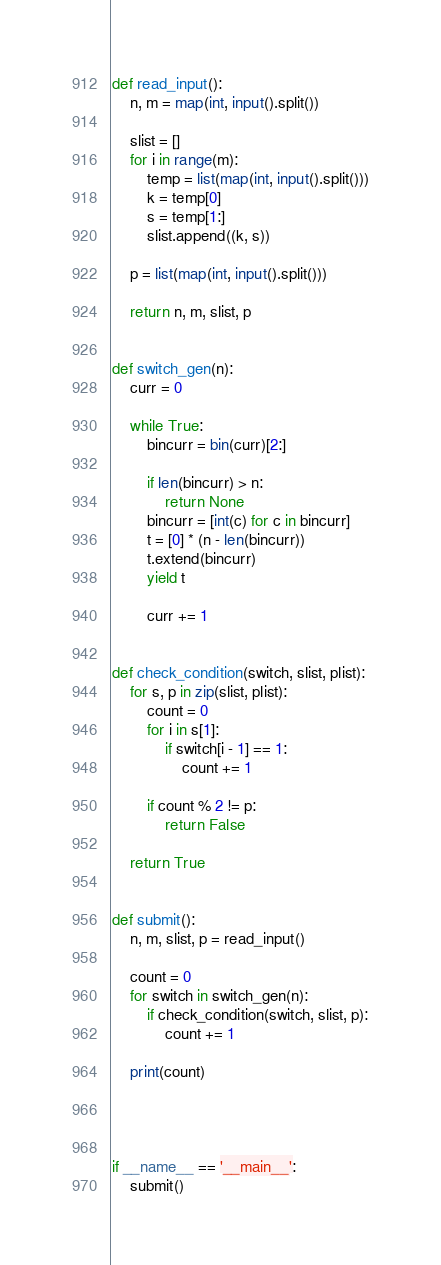<code> <loc_0><loc_0><loc_500><loc_500><_Python_>

def read_input():
    n, m = map(int, input().split())

    slist = []
    for i in range(m):
        temp = list(map(int, input().split()))
        k = temp[0]
        s = temp[1:]
        slist.append((k, s))

    p = list(map(int, input().split()))

    return n, m, slist, p


def switch_gen(n):
    curr = 0

    while True:
        bincurr = bin(curr)[2:]

        if len(bincurr) > n:
            return None
        bincurr = [int(c) for c in bincurr]
        t = [0] * (n - len(bincurr))
        t.extend(bincurr)
        yield t

        curr += 1


def check_condition(switch, slist, plist):
    for s, p in zip(slist, plist):
        count = 0
        for i in s[1]:
            if switch[i - 1] == 1:
                count += 1

        if count % 2 != p:
            return False

    return True


def submit():
    n, m, slist, p = read_input()

    count = 0
    for switch in switch_gen(n):
        if check_condition(switch, slist, p):
            count += 1

    print(count)




if __name__ == '__main__':
    submit()
</code> 